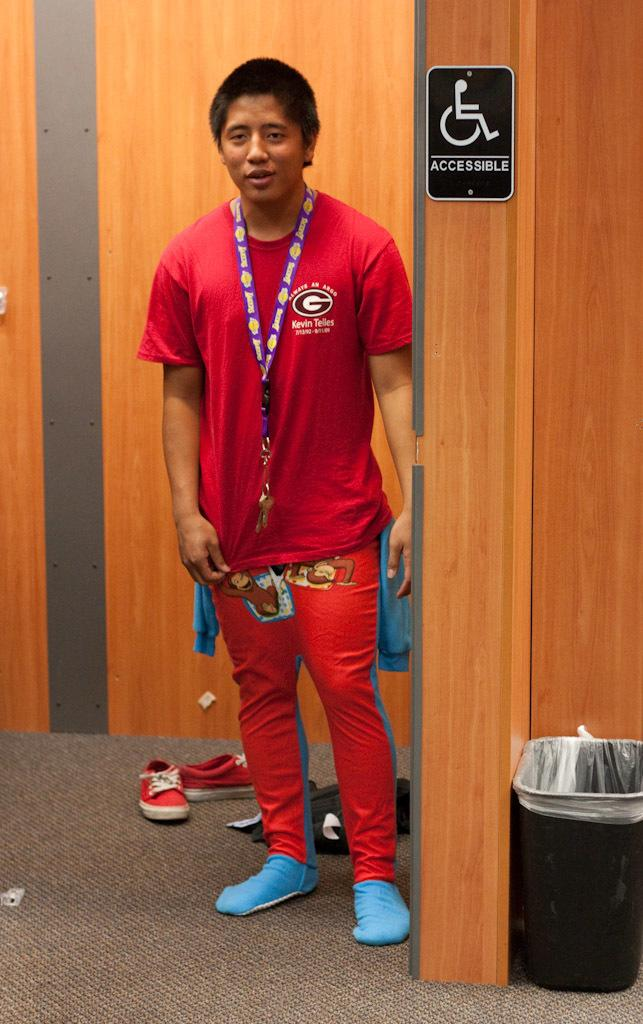<image>
Render a clear and concise summary of the photo. A man dressed in all red standing next to a handicap accessible bathroom. 